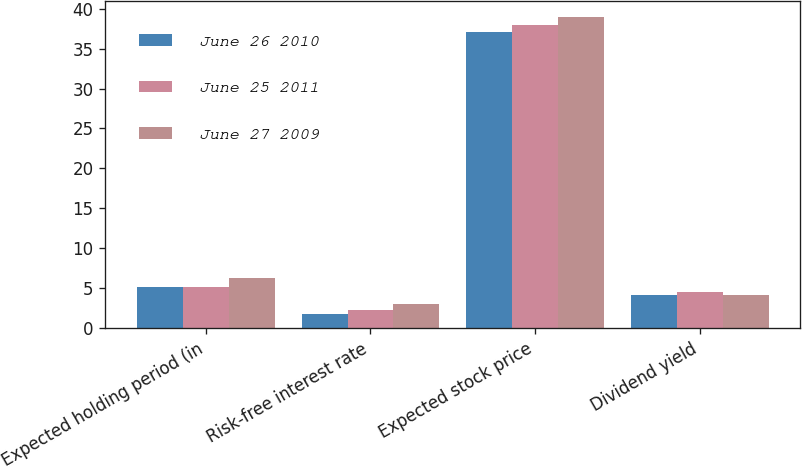<chart> <loc_0><loc_0><loc_500><loc_500><stacked_bar_chart><ecel><fcel>Expected holding period (in<fcel>Risk-free interest rate<fcel>Expected stock price<fcel>Dividend yield<nl><fcel>June 26 2010<fcel>5.2<fcel>1.7<fcel>37.1<fcel>4.2<nl><fcel>June 25 2011<fcel>5.2<fcel>2.3<fcel>38<fcel>4.5<nl><fcel>June 27 2009<fcel>6.3<fcel>3<fcel>39<fcel>4.1<nl></chart> 